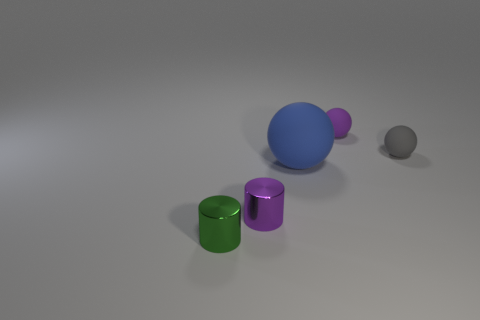Are any tiny purple spheres visible?
Keep it short and to the point. Yes. There is a purple object that is made of the same material as the large blue ball; what is its shape?
Offer a terse response. Sphere. There is a small shiny thing that is in front of the purple metallic thing that is left of the small purple thing that is behind the gray sphere; what is its color?
Provide a short and direct response. Green. Are there an equal number of big rubber things that are on the left side of the tiny purple cylinder and tiny red metal balls?
Keep it short and to the point. Yes. Is there a tiny purple shiny thing that is right of the large matte sphere on the right side of the thing to the left of the purple shiny cylinder?
Offer a terse response. No. Are there fewer tiny cylinders that are behind the green shiny cylinder than purple objects?
Give a very brief answer. Yes. What number of other things are the same shape as the green thing?
Your answer should be compact. 1. How many things are either objects that are on the left side of the small purple rubber object or tiny rubber objects left of the small gray sphere?
Keep it short and to the point. 4. What is the size of the sphere that is left of the gray ball and in front of the purple rubber ball?
Ensure brevity in your answer.  Large. There is a purple thing in front of the big object; is its shape the same as the green object?
Make the answer very short. Yes. 